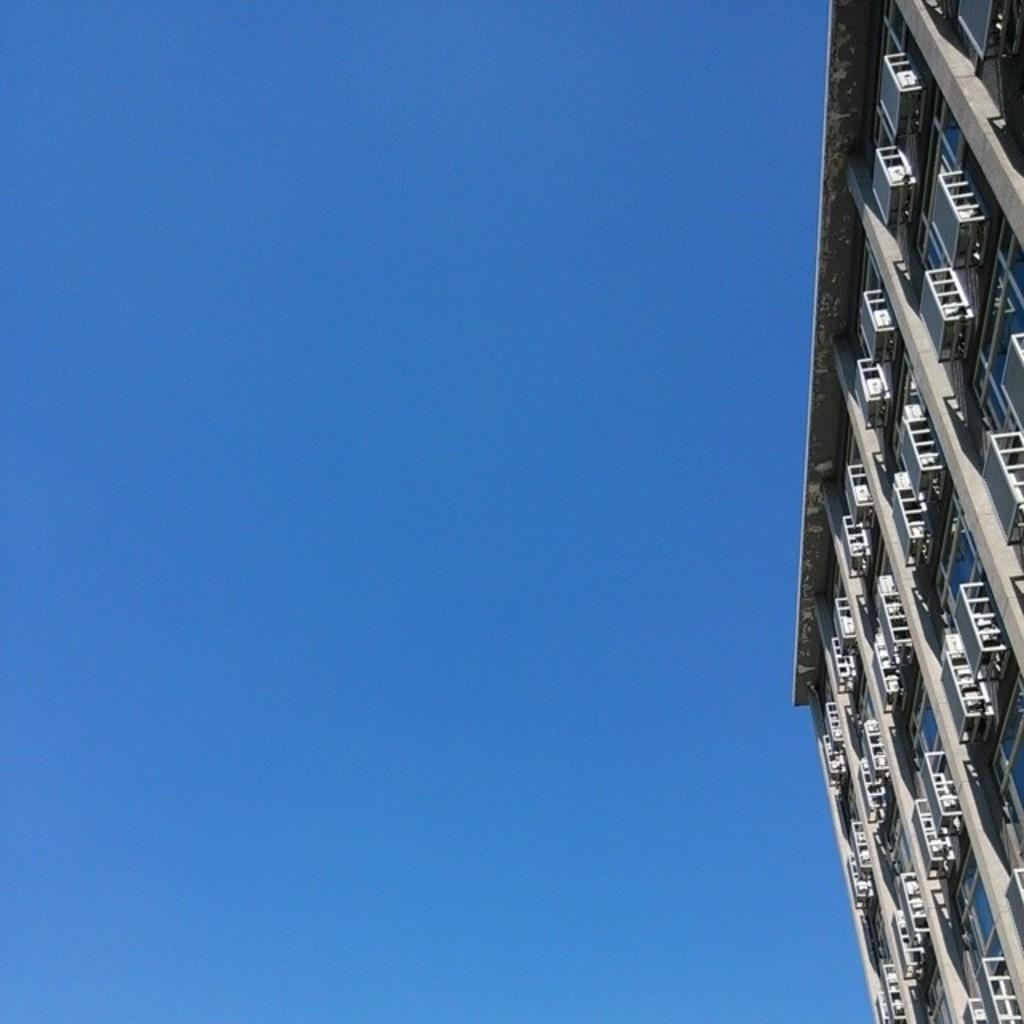What type of structure is depicted in the image? There is a building with pillars in the image. Are there any unique features on the building? Yes, there are hills attached to the building walls in the image. What can be seen in the background of the image? The sky is visible in the image. What is the color of the sky in the image? The color of the sky is blue. What type of legal advice is the building offering in the image? The image does not depict a building offering legal advice; it is simply a building with unique features and a blue sky in the background. 